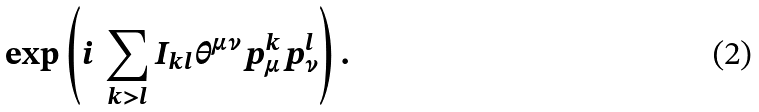Convert formula to latex. <formula><loc_0><loc_0><loc_500><loc_500>\exp \left ( i \, \sum _ { k > l } I _ { k l } \theta ^ { \mu \nu } p _ { \mu } ^ { k } p _ { \nu } ^ { l } \right ) .</formula> 